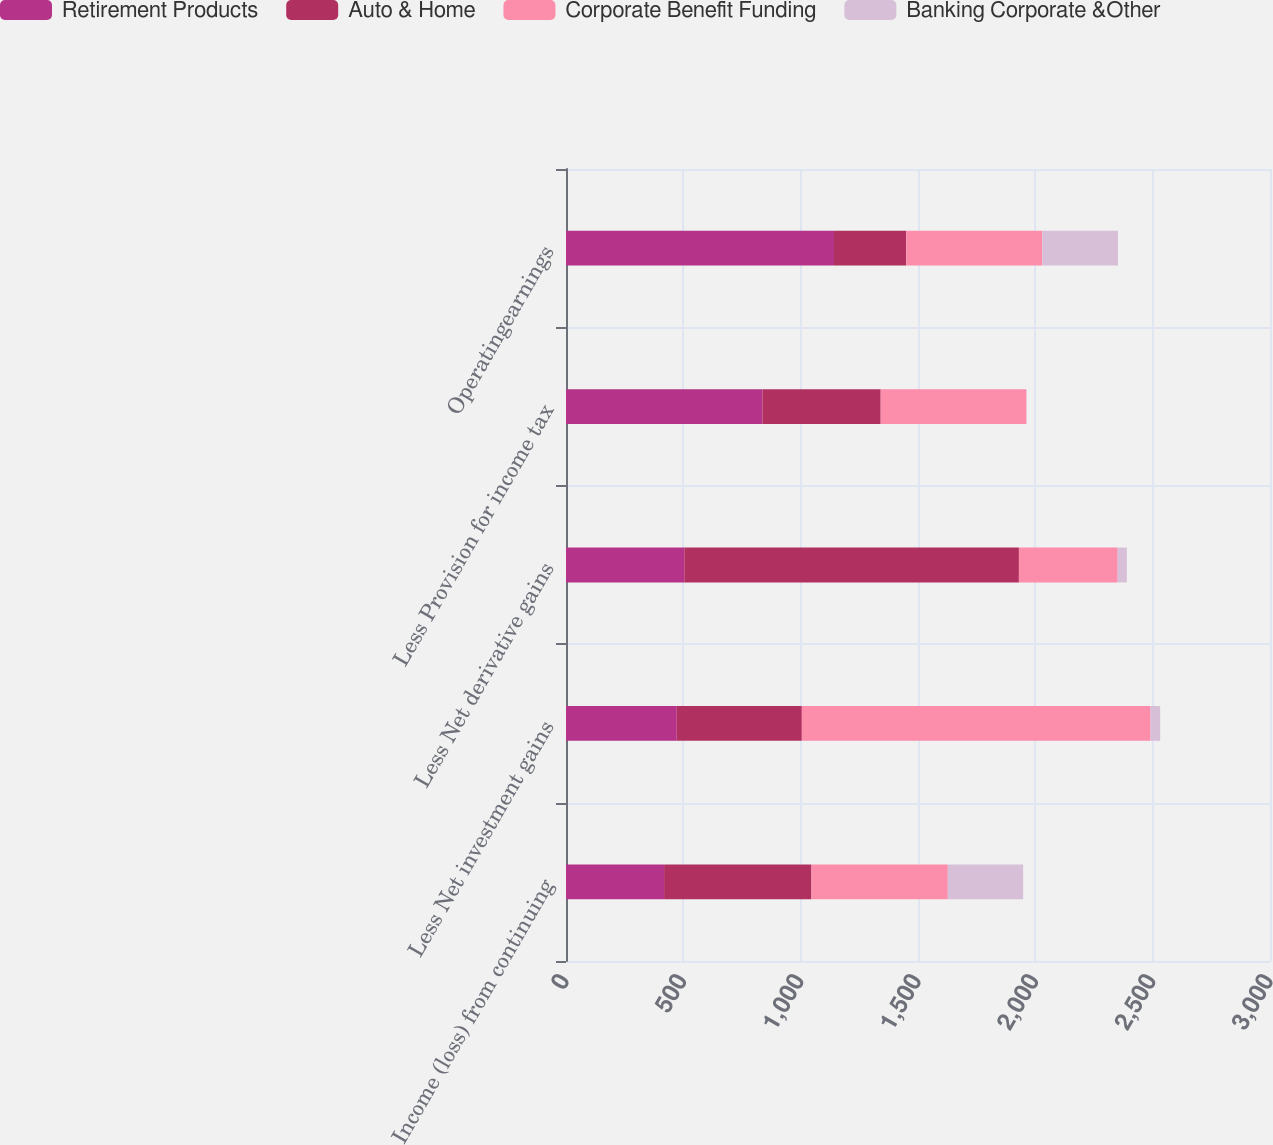Convert chart. <chart><loc_0><loc_0><loc_500><loc_500><stacked_bar_chart><ecel><fcel>Income (loss) from continuing<fcel>Less Net investment gains<fcel>Less Net derivative gains<fcel>Less Provision for income tax<fcel>Operatingearnings<nl><fcel>Retirement Products<fcel>418<fcel>472<fcel>504<fcel>837<fcel>1142<nl><fcel>Auto & Home<fcel>628<fcel>533<fcel>1426<fcel>504<fcel>308<nl><fcel>Corporate Benefit Funding<fcel>581<fcel>1486<fcel>421<fcel>621<fcel>580<nl><fcel>Banking Corporate &Other<fcel>321<fcel>41<fcel>39<fcel>1<fcel>322<nl></chart> 